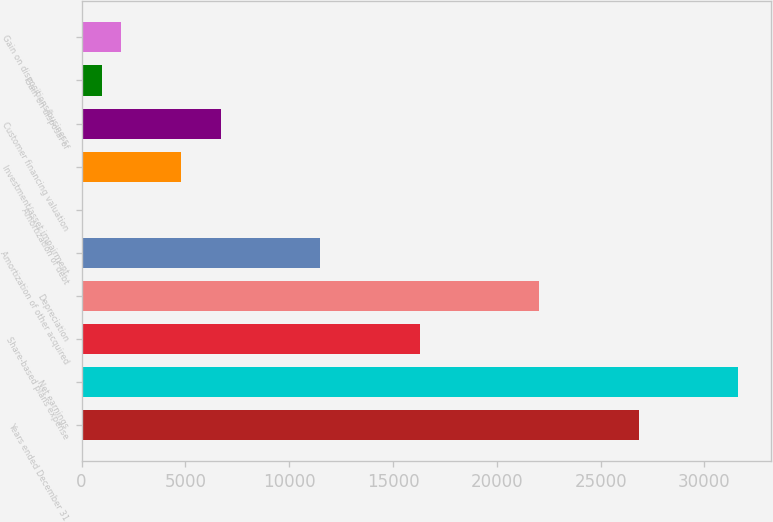<chart> <loc_0><loc_0><loc_500><loc_500><bar_chart><fcel>Years ended December 31<fcel>Net earnings<fcel>Share-based plans expense<fcel>Depreciation<fcel>Amortization of other acquired<fcel>Amortization of debt<fcel>Investment/asset impairment<fcel>Customer financing valuation<fcel>Gain on disposal of<fcel>Gain on dispositions/business<nl><fcel>26833.4<fcel>31624.9<fcel>16292.1<fcel>22041.9<fcel>11500.6<fcel>1<fcel>4792.5<fcel>6709.1<fcel>959.3<fcel>1917.6<nl></chart> 